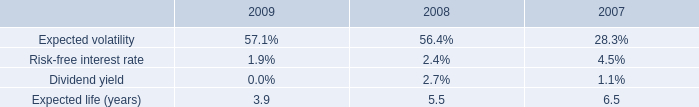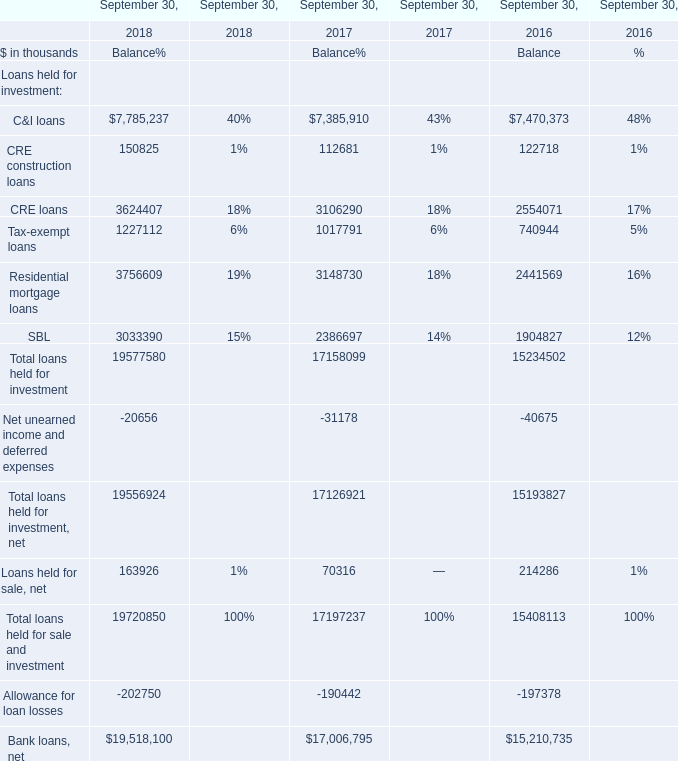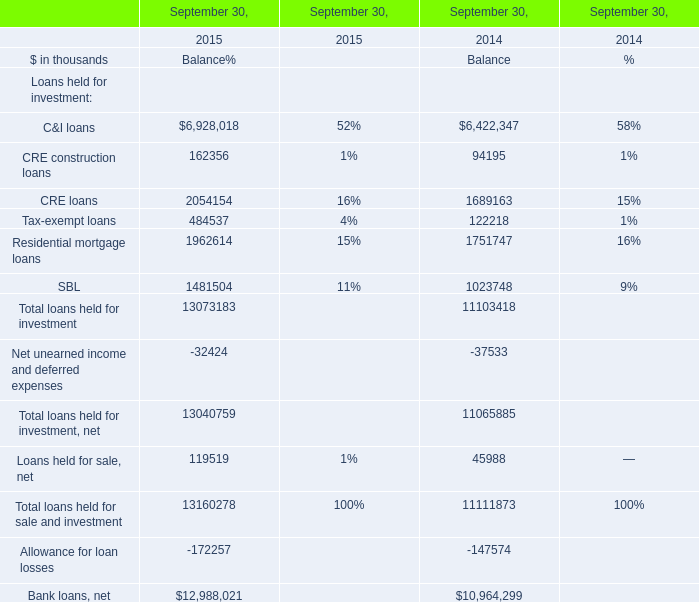What will Balance for CRE loans on September 30 be like in 2016 if it develops with the same increasing rate as current? (in thousand) 
Computations: (2054154 * (1 + ((2054154 - 1689163) / 1689163)))
Answer: 2498011.53335. 